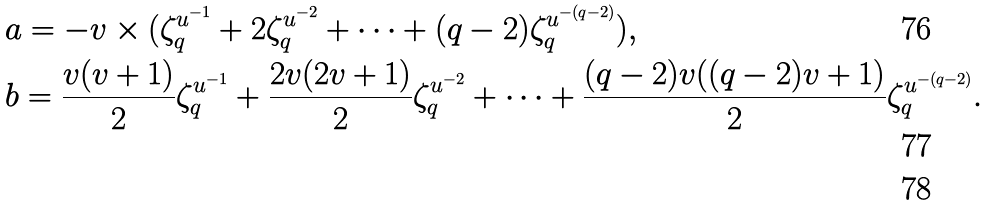Convert formula to latex. <formula><loc_0><loc_0><loc_500><loc_500>& a = - v \times ( \zeta _ { q } ^ { u ^ { - 1 } } + 2 \zeta _ { q } ^ { u ^ { - 2 } } + \dots + ( q - 2 ) \zeta _ { q } ^ { u ^ { - ( q - 2 ) } } ) , \\ & b = \frac { v ( v + 1 ) } { 2 } \zeta _ { q } ^ { u ^ { - 1 } } + \frac { 2 v ( 2 v + 1 ) } { 2 } \zeta _ { q } ^ { u ^ { - 2 } } + \dots + \frac { ( q - 2 ) v ( ( q - 2 ) v + 1 ) } { 2 } \zeta _ { q } ^ { u ^ { - ( q - 2 ) } } . \\</formula> 